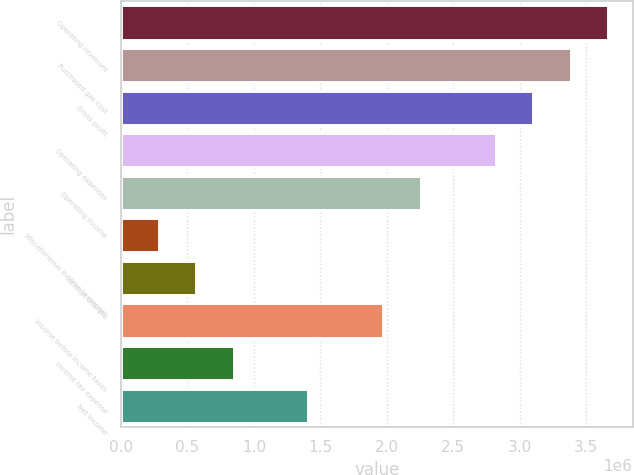Convert chart. <chart><loc_0><loc_0><loc_500><loc_500><bar_chart><fcel>Operating revenues<fcel>Purchased gas cost<fcel>Gross profit<fcel>Operating expenses<fcel>Operating income<fcel>Miscellaneous income (expense)<fcel>Interest charges<fcel>Income before income taxes<fcel>Income tax expense<fcel>Net income<nl><fcel>3.66777e+06<fcel>3.38563e+06<fcel>3.1035e+06<fcel>2.82136e+06<fcel>2.25709e+06<fcel>282141<fcel>564276<fcel>1.97495e+06<fcel>846412<fcel>1.41068e+06<nl></chart> 